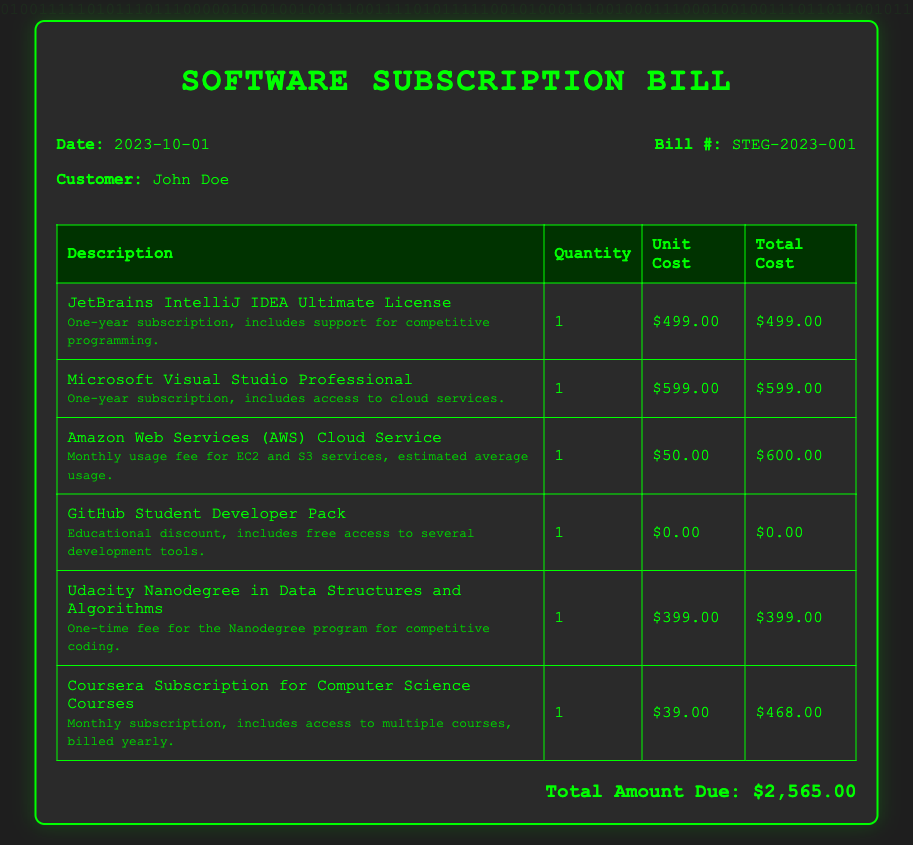What is the date of the bill? The date of the bill is explicitly mentioned in the document as "2023-10-01."
Answer: 2023-10-01 Who is the customer named in the bill? The document specifies that the customer is John Doe.
Answer: John Doe What is the total amount due? The total amount due is calculated at the bottom of the document and is $2,565.00.
Answer: $2,565.00 How much does the Microsoft Visual Studio Professional cost? The bill lists the unit cost for Microsoft Visual Studio Professional as $599.00.
Answer: $599.00 What is included in the GitHub Student Developer Pack? The document states that the GitHub Student Developer Pack includes free access to several development tools, indicating an educational focus.
Answer: Free access to several development tools What is the one-time fee for the Udacity Nanodegree program? The document indicates that the fee for the Udacity Nanodegree in Data Structures and Algorithms is $399.00.
Answer: $399.00 What is the total cost for the AWS Cloud Service listed in the bill? The total cost is specified in the document as $600.00 derived from a monthly usage fee for EC2 and S3 services.
Answer: $600.00 Which development tool license has a one-year subscription? Both JetBrains IntelliJ IDEA Ultimate License and Microsoft Visual Studio Professional have one-year subscriptions mentioned.
Answer: JetBrains IntelliJ IDEA Ultimate License and Microsoft Visual Studio Professional How often is the Coursera Subscription billed? The document states that the Coursera Subscription is billed yearly, indicating it is a monthly subscription charged once a year.
Answer: Yearly 